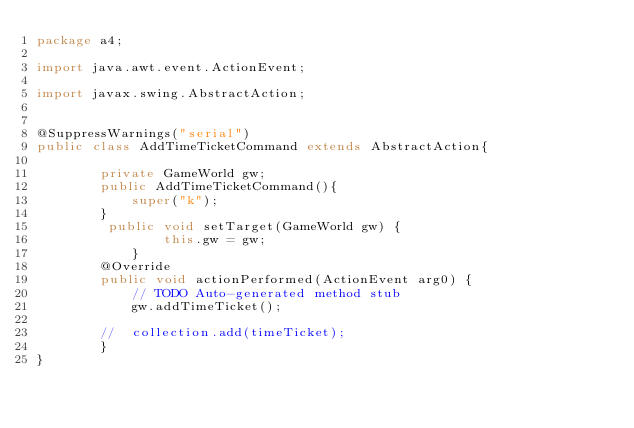<code> <loc_0><loc_0><loc_500><loc_500><_Java_>package a4;

import java.awt.event.ActionEvent;

import javax.swing.AbstractAction;


@SuppressWarnings("serial")
public class AddTimeTicketCommand extends AbstractAction{

		private GameWorld gw;
		public AddTimeTicketCommand(){
			super("k");
		}
		 public void setTarget(GameWorld gw) {
		        this.gw = gw;
		    }
		@Override
		public void actionPerformed(ActionEvent arg0) {
			// TODO Auto-generated method stub
			gw.addTimeTicket();
	
		//	collection.add(timeTicket);
		}
}
</code> 